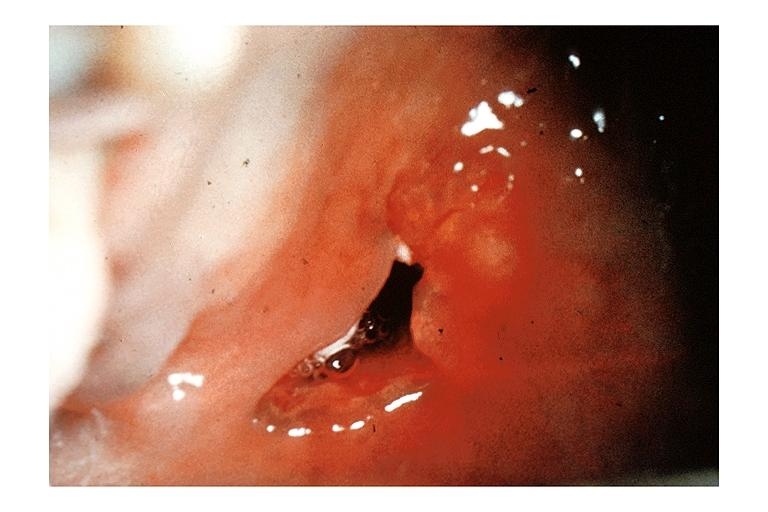what does this image show?
Answer the question using a single word or phrase. Mucoepidermoid carcinoma 